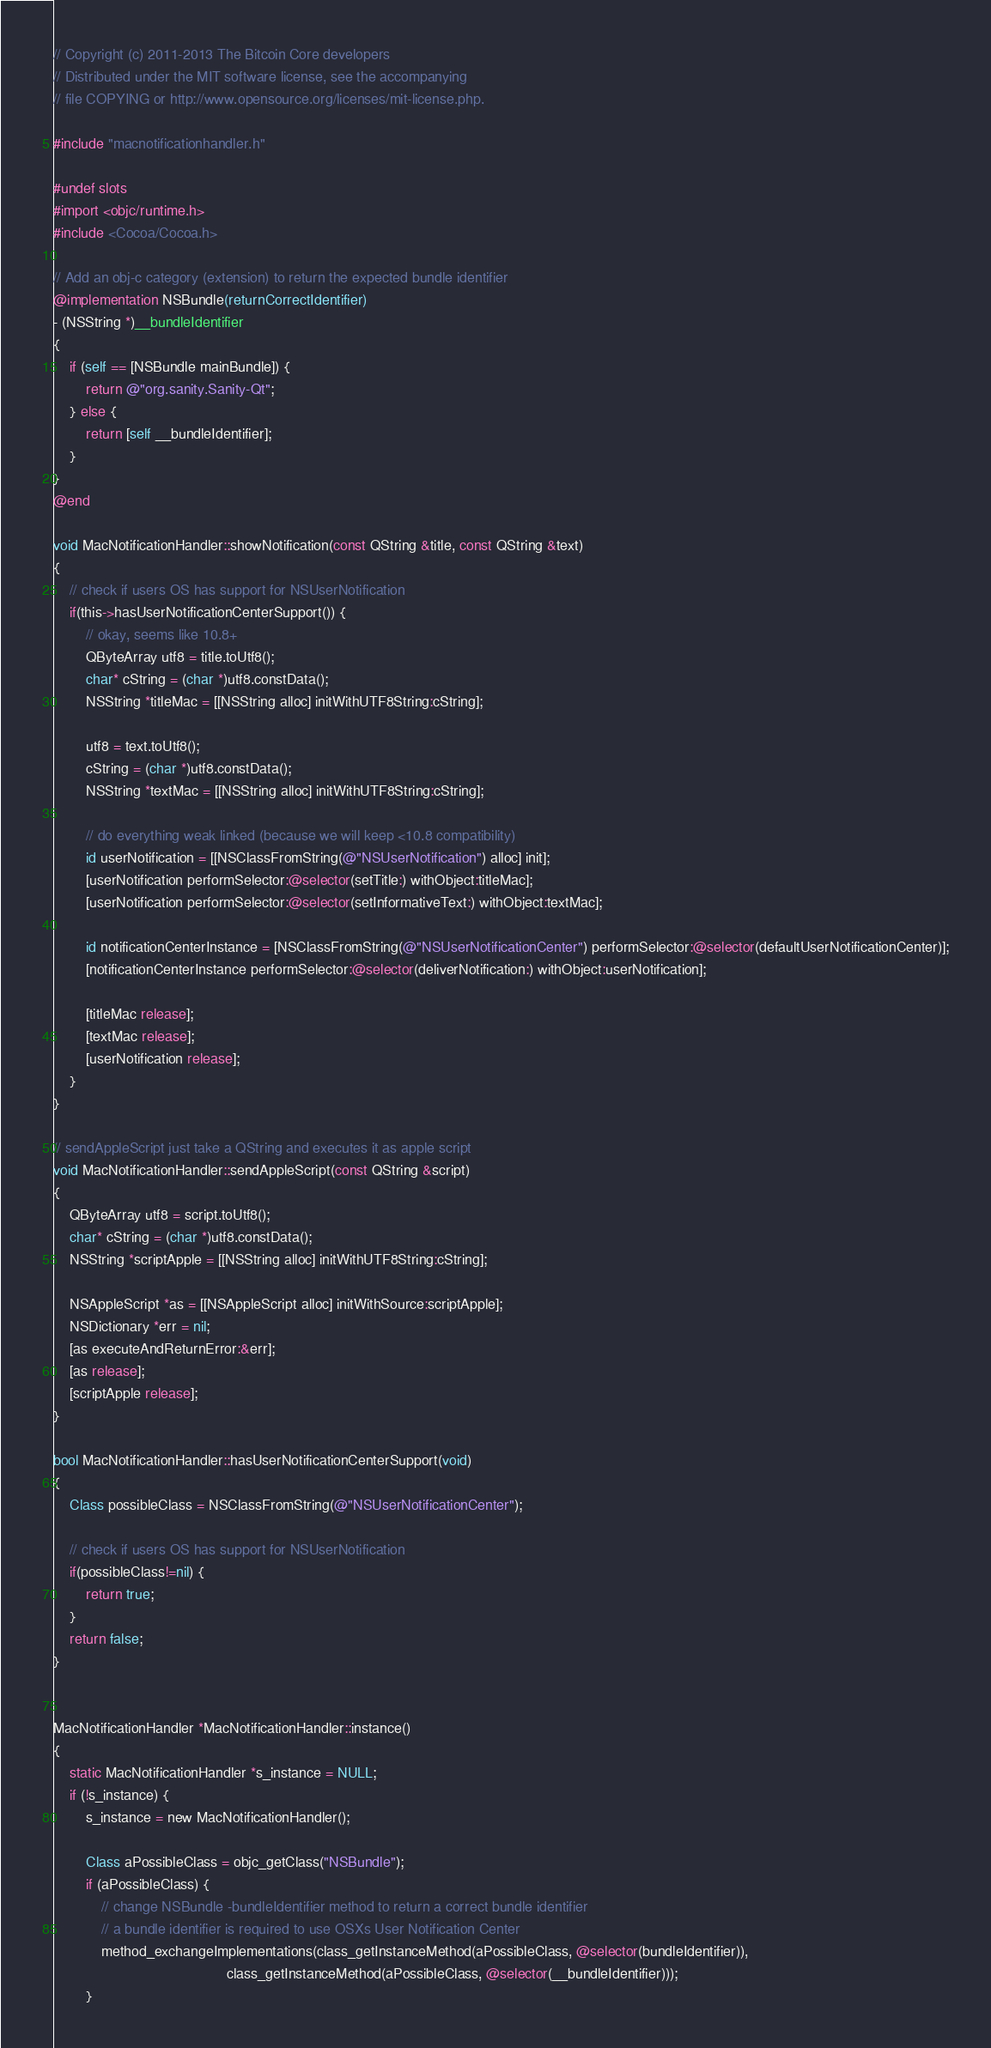Convert code to text. <code><loc_0><loc_0><loc_500><loc_500><_ObjectiveC_>// Copyright (c) 2011-2013 The Bitcoin Core developers
// Distributed under the MIT software license, see the accompanying
// file COPYING or http://www.opensource.org/licenses/mit-license.php.

#include "macnotificationhandler.h"

#undef slots
#import <objc/runtime.h>
#include <Cocoa/Cocoa.h>

// Add an obj-c category (extension) to return the expected bundle identifier
@implementation NSBundle(returnCorrectIdentifier)
- (NSString *)__bundleIdentifier
{
    if (self == [NSBundle mainBundle]) {
        return @"org.sanity.Sanity-Qt";
    } else {
        return [self __bundleIdentifier];
    }
}
@end

void MacNotificationHandler::showNotification(const QString &title, const QString &text)
{
    // check if users OS has support for NSUserNotification
    if(this->hasUserNotificationCenterSupport()) {
        // okay, seems like 10.8+
        QByteArray utf8 = title.toUtf8();
        char* cString = (char *)utf8.constData();
        NSString *titleMac = [[NSString alloc] initWithUTF8String:cString];

        utf8 = text.toUtf8();
        cString = (char *)utf8.constData();
        NSString *textMac = [[NSString alloc] initWithUTF8String:cString];

        // do everything weak linked (because we will keep <10.8 compatibility)
        id userNotification = [[NSClassFromString(@"NSUserNotification") alloc] init];
        [userNotification performSelector:@selector(setTitle:) withObject:titleMac];
        [userNotification performSelector:@selector(setInformativeText:) withObject:textMac];

        id notificationCenterInstance = [NSClassFromString(@"NSUserNotificationCenter") performSelector:@selector(defaultUserNotificationCenter)];
        [notificationCenterInstance performSelector:@selector(deliverNotification:) withObject:userNotification];

        [titleMac release];
        [textMac release];
        [userNotification release];
    }
}

// sendAppleScript just take a QString and executes it as apple script
void MacNotificationHandler::sendAppleScript(const QString &script)
{
    QByteArray utf8 = script.toUtf8();
    char* cString = (char *)utf8.constData();
    NSString *scriptApple = [[NSString alloc] initWithUTF8String:cString];

    NSAppleScript *as = [[NSAppleScript alloc] initWithSource:scriptApple];
    NSDictionary *err = nil;
    [as executeAndReturnError:&err];
    [as release];
    [scriptApple release];
}

bool MacNotificationHandler::hasUserNotificationCenterSupport(void)
{
    Class possibleClass = NSClassFromString(@"NSUserNotificationCenter");

    // check if users OS has support for NSUserNotification
    if(possibleClass!=nil) {
        return true;
    }
    return false;
}


MacNotificationHandler *MacNotificationHandler::instance()
{
    static MacNotificationHandler *s_instance = NULL;
    if (!s_instance) {
        s_instance = new MacNotificationHandler();
        
        Class aPossibleClass = objc_getClass("NSBundle");
        if (aPossibleClass) {
            // change NSBundle -bundleIdentifier method to return a correct bundle identifier
            // a bundle identifier is required to use OSXs User Notification Center
            method_exchangeImplementations(class_getInstanceMethod(aPossibleClass, @selector(bundleIdentifier)),
                                           class_getInstanceMethod(aPossibleClass, @selector(__bundleIdentifier)));
        }</code> 